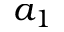<formula> <loc_0><loc_0><loc_500><loc_500>a _ { 1 }</formula> 